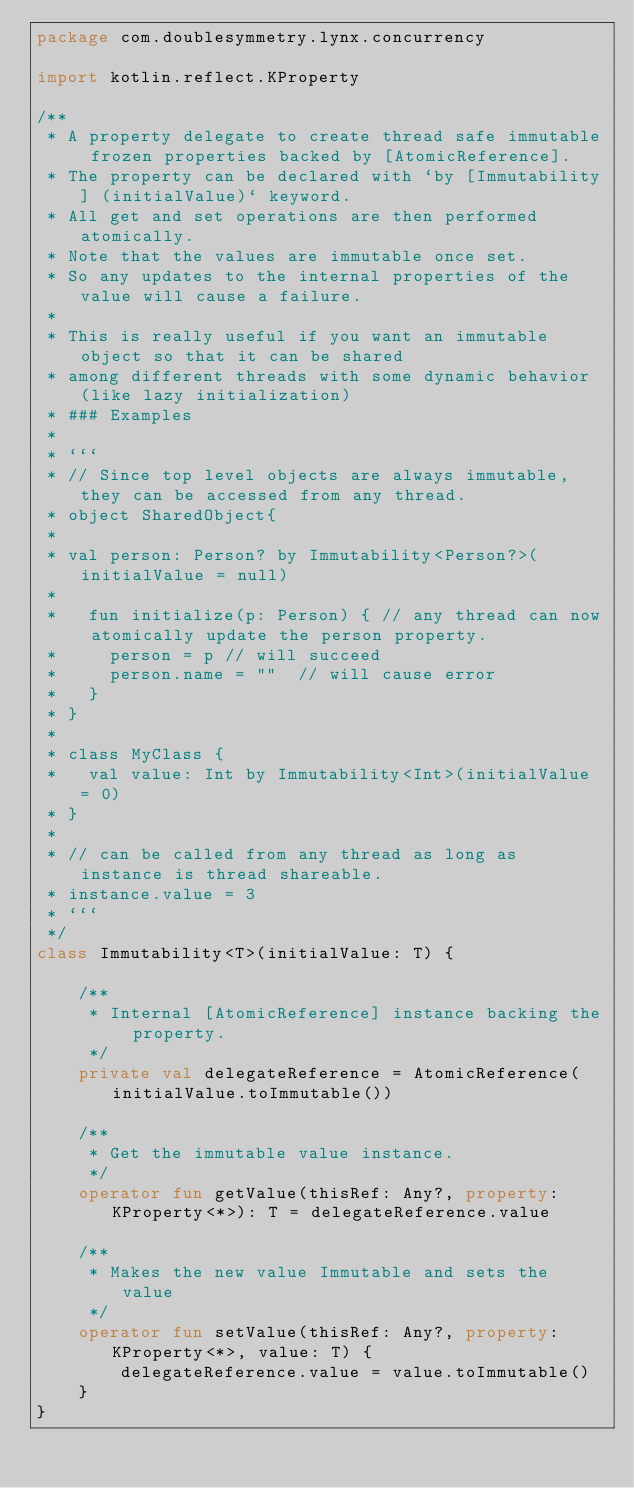Convert code to text. <code><loc_0><loc_0><loc_500><loc_500><_Kotlin_>package com.doublesymmetry.lynx.concurrency

import kotlin.reflect.KProperty

/**
 * A property delegate to create thread safe immutable frozen properties backed by [AtomicReference].
 * The property can be declared with `by [Immutability] (initialValue)` keyword.
 * All get and set operations are then performed atomically.
 * Note that the values are immutable once set.
 * So any updates to the internal properties of the value will cause a failure.
 *
 * This is really useful if you want an immutable object so that it can be shared
 * among different threads with some dynamic behavior (like lazy initialization)
 * ### Examples
 *
 * ```
 * // Since top level objects are always immutable, they can be accessed from any thread.
 * object SharedObject{
 *
 * val person: Person? by Immutability<Person?>(initialValue = null)
 *
 *   fun initialize(p: Person) { // any thread can now atomically update the person property.
 *     person = p // will succeed
 *     person.name = ""  // will cause error
 *   }
 * }
 *
 * class MyClass {
 *   val value: Int by Immutability<Int>(initialValue = 0)
 * }
 *
 * // can be called from any thread as long as instance is thread shareable.
 * instance.value = 3
 * ```
 */
class Immutability<T>(initialValue: T) {

    /**
     * Internal [AtomicReference] instance backing the property.
     */
    private val delegateReference = AtomicReference(initialValue.toImmutable())

    /**
     * Get the immutable value instance.
     */
    operator fun getValue(thisRef: Any?, property: KProperty<*>): T = delegateReference.value

    /**
     * Makes the new value Immutable and sets the value
     */
    operator fun setValue(thisRef: Any?, property: KProperty<*>, value: T) {
        delegateReference.value = value.toImmutable()
    }
}</code> 